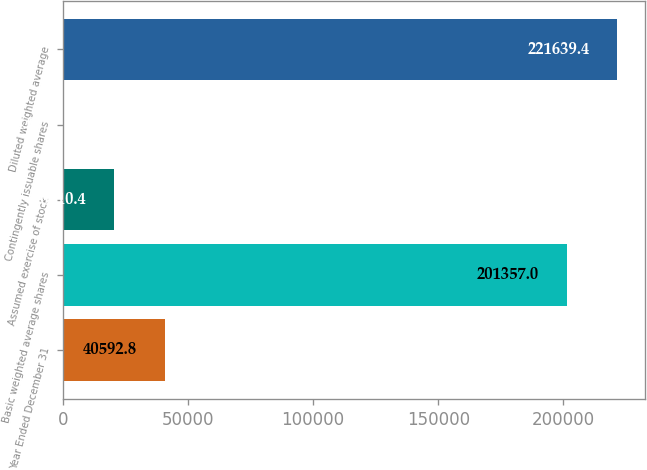Convert chart to OTSL. <chart><loc_0><loc_0><loc_500><loc_500><bar_chart><fcel>Year Ended December 31<fcel>Basic weighted average shares<fcel>Assumed exercise of stock<fcel>Contingently issuable shares<fcel>Diluted weighted average<nl><fcel>40592.8<fcel>201357<fcel>20310.4<fcel>28<fcel>221639<nl></chart> 